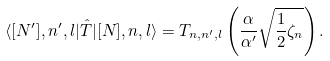<formula> <loc_0><loc_0><loc_500><loc_500>\langle [ N ^ { \prime } ] , n ^ { \prime } , l | \hat { T } | [ N ] , n , l \rangle = T _ { n , n ^ { \prime } , l } \left ( \frac { \alpha } { \alpha ^ { \prime } } \sqrt { \frac { 1 } { 2 } \zeta _ { n } } \right ) .</formula> 